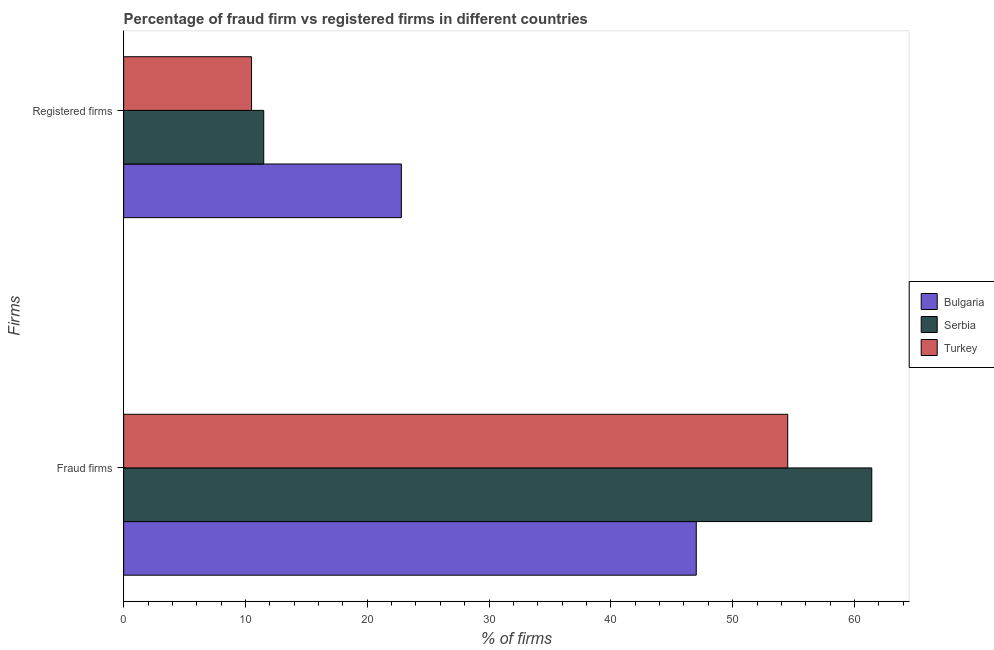How many different coloured bars are there?
Offer a terse response. 3. Are the number of bars per tick equal to the number of legend labels?
Make the answer very short. Yes. Are the number of bars on each tick of the Y-axis equal?
Provide a short and direct response. Yes. What is the label of the 2nd group of bars from the top?
Your answer should be compact. Fraud firms. What is the percentage of fraud firms in Serbia?
Ensure brevity in your answer.  61.42. Across all countries, what is the maximum percentage of registered firms?
Keep it short and to the point. 22.8. What is the total percentage of fraud firms in the graph?
Give a very brief answer. 162.95. What is the difference between the percentage of registered firms in Bulgaria and that in Turkey?
Provide a succinct answer. 12.3. What is the difference between the percentage of fraud firms in Serbia and the percentage of registered firms in Turkey?
Give a very brief answer. 50.92. What is the average percentage of fraud firms per country?
Your answer should be compact. 54.32. What is the difference between the percentage of fraud firms and percentage of registered firms in Bulgaria?
Ensure brevity in your answer.  24.21. In how many countries, is the percentage of fraud firms greater than 48 %?
Your answer should be compact. 2. What is the ratio of the percentage of fraud firms in Bulgaria to that in Serbia?
Make the answer very short. 0.77. Is the percentage of fraud firms in Bulgaria less than that in Serbia?
Provide a short and direct response. Yes. What does the 2nd bar from the top in Fraud firms represents?
Provide a succinct answer. Serbia. How many bars are there?
Offer a very short reply. 6. What is the difference between two consecutive major ticks on the X-axis?
Provide a succinct answer. 10. Are the values on the major ticks of X-axis written in scientific E-notation?
Ensure brevity in your answer.  No. How many legend labels are there?
Ensure brevity in your answer.  3. What is the title of the graph?
Provide a short and direct response. Percentage of fraud firm vs registered firms in different countries. What is the label or title of the X-axis?
Your answer should be compact. % of firms. What is the label or title of the Y-axis?
Give a very brief answer. Firms. What is the % of firms in Bulgaria in Fraud firms?
Provide a short and direct response. 47.01. What is the % of firms of Serbia in Fraud firms?
Offer a terse response. 61.42. What is the % of firms of Turkey in Fraud firms?
Your answer should be very brief. 54.52. What is the % of firms of Bulgaria in Registered firms?
Offer a very short reply. 22.8. What is the % of firms of Turkey in Registered firms?
Provide a short and direct response. 10.5. Across all Firms, what is the maximum % of firms of Bulgaria?
Your response must be concise. 47.01. Across all Firms, what is the maximum % of firms in Serbia?
Your response must be concise. 61.42. Across all Firms, what is the maximum % of firms in Turkey?
Provide a succinct answer. 54.52. Across all Firms, what is the minimum % of firms of Bulgaria?
Your answer should be very brief. 22.8. What is the total % of firms in Bulgaria in the graph?
Your response must be concise. 69.81. What is the total % of firms of Serbia in the graph?
Offer a terse response. 72.92. What is the total % of firms in Turkey in the graph?
Ensure brevity in your answer.  65.02. What is the difference between the % of firms in Bulgaria in Fraud firms and that in Registered firms?
Your answer should be compact. 24.21. What is the difference between the % of firms in Serbia in Fraud firms and that in Registered firms?
Make the answer very short. 49.92. What is the difference between the % of firms in Turkey in Fraud firms and that in Registered firms?
Keep it short and to the point. 44.02. What is the difference between the % of firms in Bulgaria in Fraud firms and the % of firms in Serbia in Registered firms?
Ensure brevity in your answer.  35.51. What is the difference between the % of firms in Bulgaria in Fraud firms and the % of firms in Turkey in Registered firms?
Provide a short and direct response. 36.51. What is the difference between the % of firms of Serbia in Fraud firms and the % of firms of Turkey in Registered firms?
Provide a succinct answer. 50.92. What is the average % of firms of Bulgaria per Firms?
Provide a short and direct response. 34.91. What is the average % of firms in Serbia per Firms?
Provide a succinct answer. 36.46. What is the average % of firms of Turkey per Firms?
Your response must be concise. 32.51. What is the difference between the % of firms in Bulgaria and % of firms in Serbia in Fraud firms?
Your answer should be compact. -14.41. What is the difference between the % of firms of Bulgaria and % of firms of Turkey in Fraud firms?
Ensure brevity in your answer.  -7.51. What is the difference between the % of firms of Serbia and % of firms of Turkey in Fraud firms?
Your response must be concise. 6.9. What is the difference between the % of firms of Bulgaria and % of firms of Serbia in Registered firms?
Make the answer very short. 11.3. What is the difference between the % of firms in Bulgaria and % of firms in Turkey in Registered firms?
Give a very brief answer. 12.3. What is the difference between the % of firms of Serbia and % of firms of Turkey in Registered firms?
Make the answer very short. 1. What is the ratio of the % of firms of Bulgaria in Fraud firms to that in Registered firms?
Make the answer very short. 2.06. What is the ratio of the % of firms in Serbia in Fraud firms to that in Registered firms?
Keep it short and to the point. 5.34. What is the ratio of the % of firms of Turkey in Fraud firms to that in Registered firms?
Give a very brief answer. 5.19. What is the difference between the highest and the second highest % of firms of Bulgaria?
Provide a succinct answer. 24.21. What is the difference between the highest and the second highest % of firms in Serbia?
Make the answer very short. 49.92. What is the difference between the highest and the second highest % of firms of Turkey?
Your answer should be compact. 44.02. What is the difference between the highest and the lowest % of firms in Bulgaria?
Provide a succinct answer. 24.21. What is the difference between the highest and the lowest % of firms in Serbia?
Your answer should be very brief. 49.92. What is the difference between the highest and the lowest % of firms in Turkey?
Offer a very short reply. 44.02. 